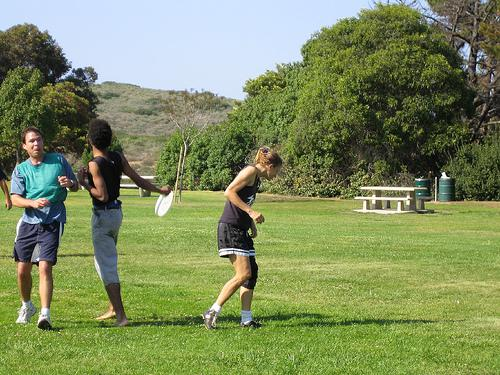Question: when was the photo taken?
Choices:
A. Midnight.
B. Mid afternoon.
C. During the day.
D. 6:00 pm.
Answer with the letter. Answer: C Question: why are the people there?
Choices:
A. For funeral.
B. To play.
C. For contest.
D. To swim.
Answer with the letter. Answer: B 